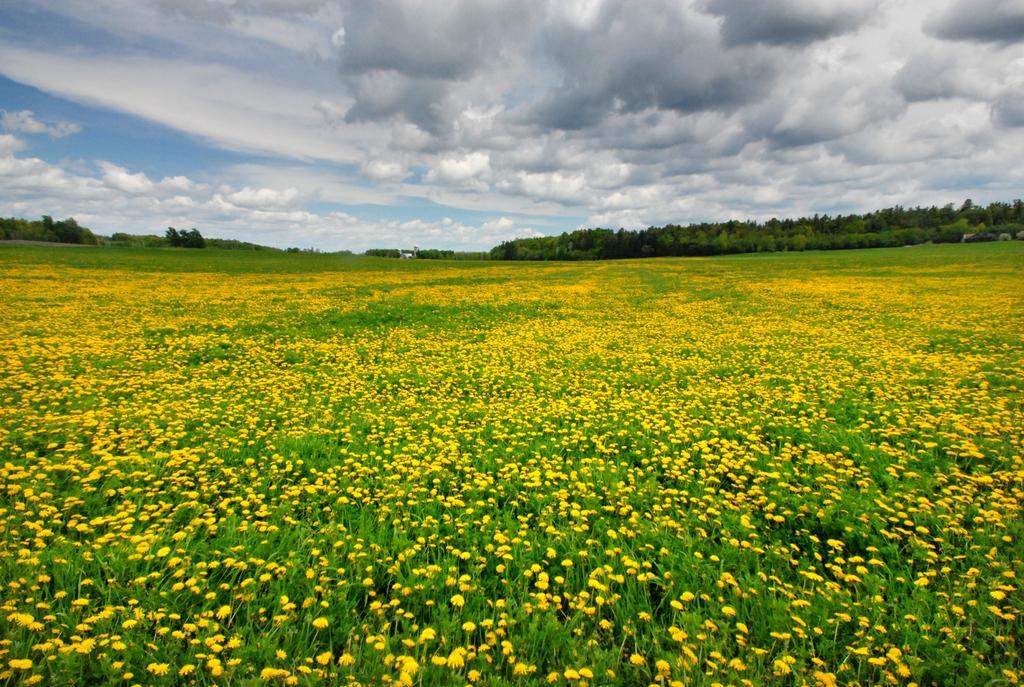How would you summarize this image in a sentence or two? In this image there are plants with yellow flowers , and at the background there are trees, sky. 